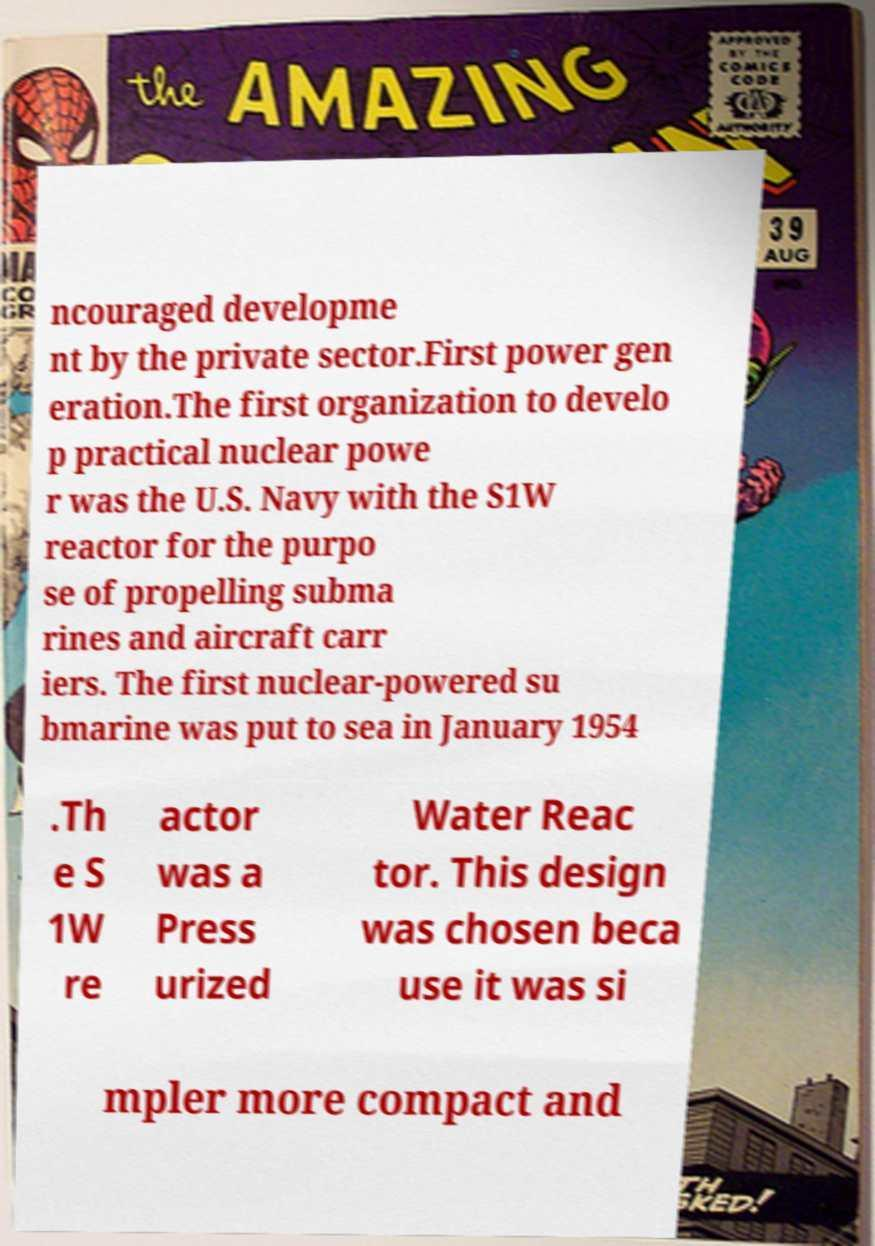What messages or text are displayed in this image? I need them in a readable, typed format. ncouraged developme nt by the private sector.First power gen eration.The first organization to develo p practical nuclear powe r was the U.S. Navy with the S1W reactor for the purpo se of propelling subma rines and aircraft carr iers. The first nuclear-powered su bmarine was put to sea in January 1954 .Th e S 1W re actor was a Press urized Water Reac tor. This design was chosen beca use it was si mpler more compact and 